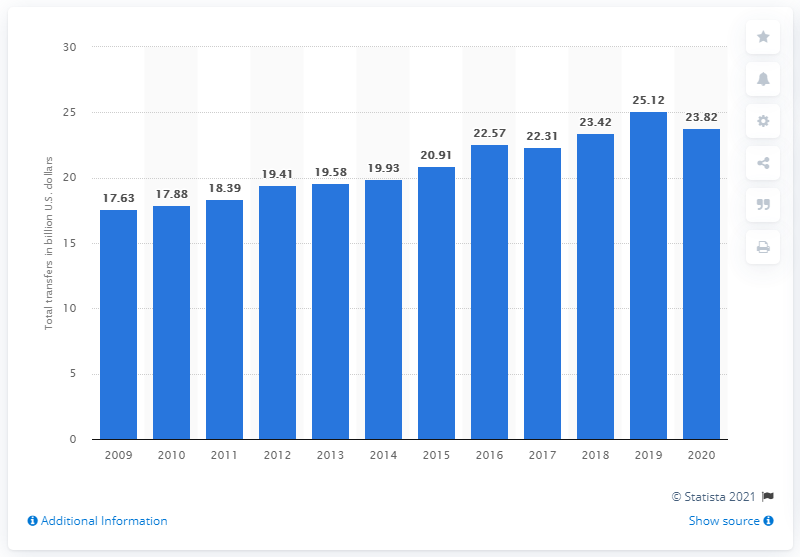Identify some key points in this picture. In 2020, state lotteries transferred a total of $23.82 to beneficiaries. The previous year's total amount of U.S. dollars transferred to beneficiaries was 25.12.. 